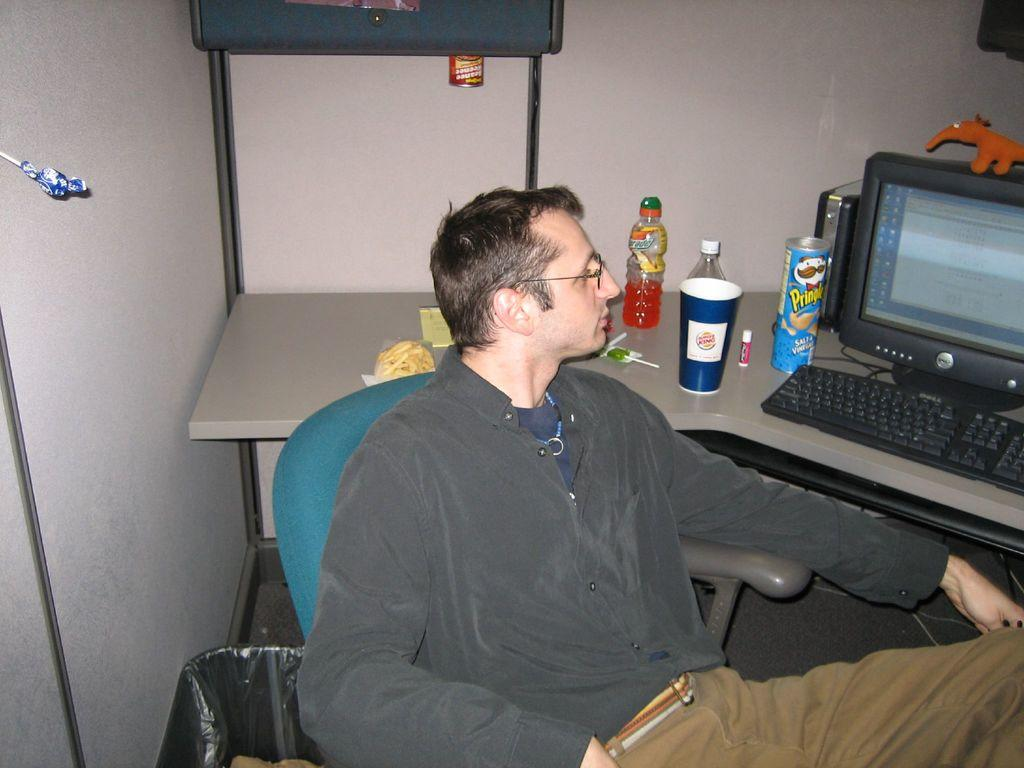<image>
Share a concise interpretation of the image provided. A man sitting in a chair looking at a Dell computer. 